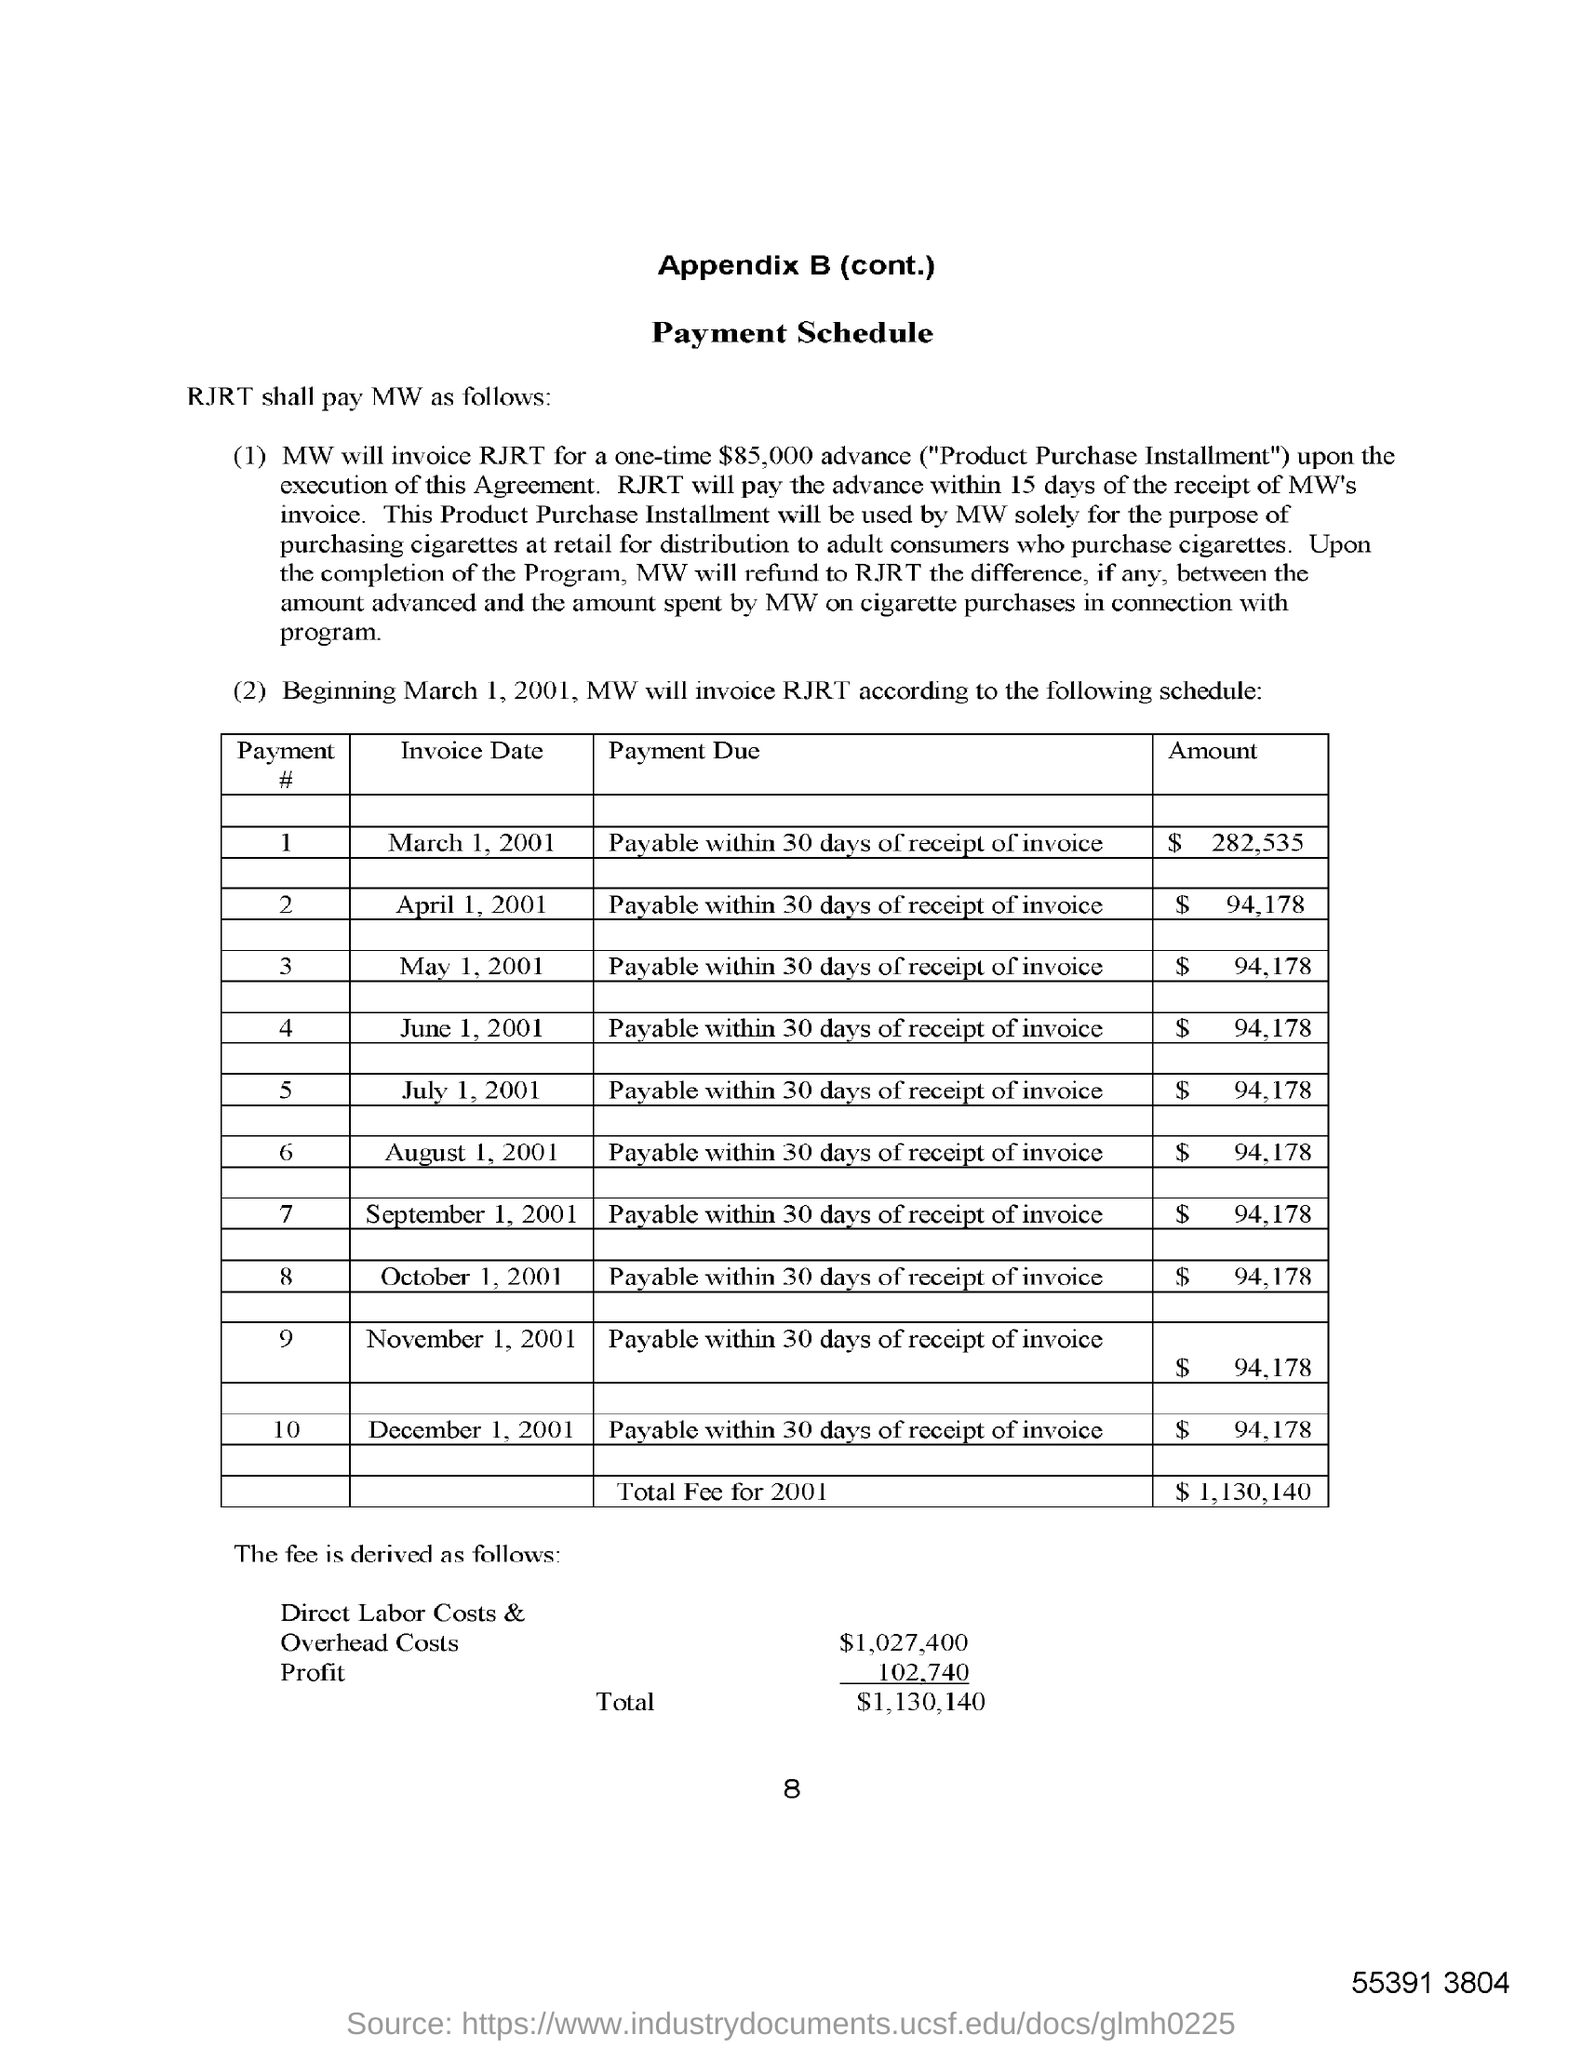What is the total fee for 2001?
Your answer should be very brief. $ 1,130,140. What is the advance amount specified as "Product Purchase Installment"?
Give a very brief answer. $85,000. What is the invoice date for the amount $282,535?
Offer a terse response. March 1, 2001. What is the payment due for all the invoices?
Keep it short and to the point. Payable within 30 days of receipt of invoice. 